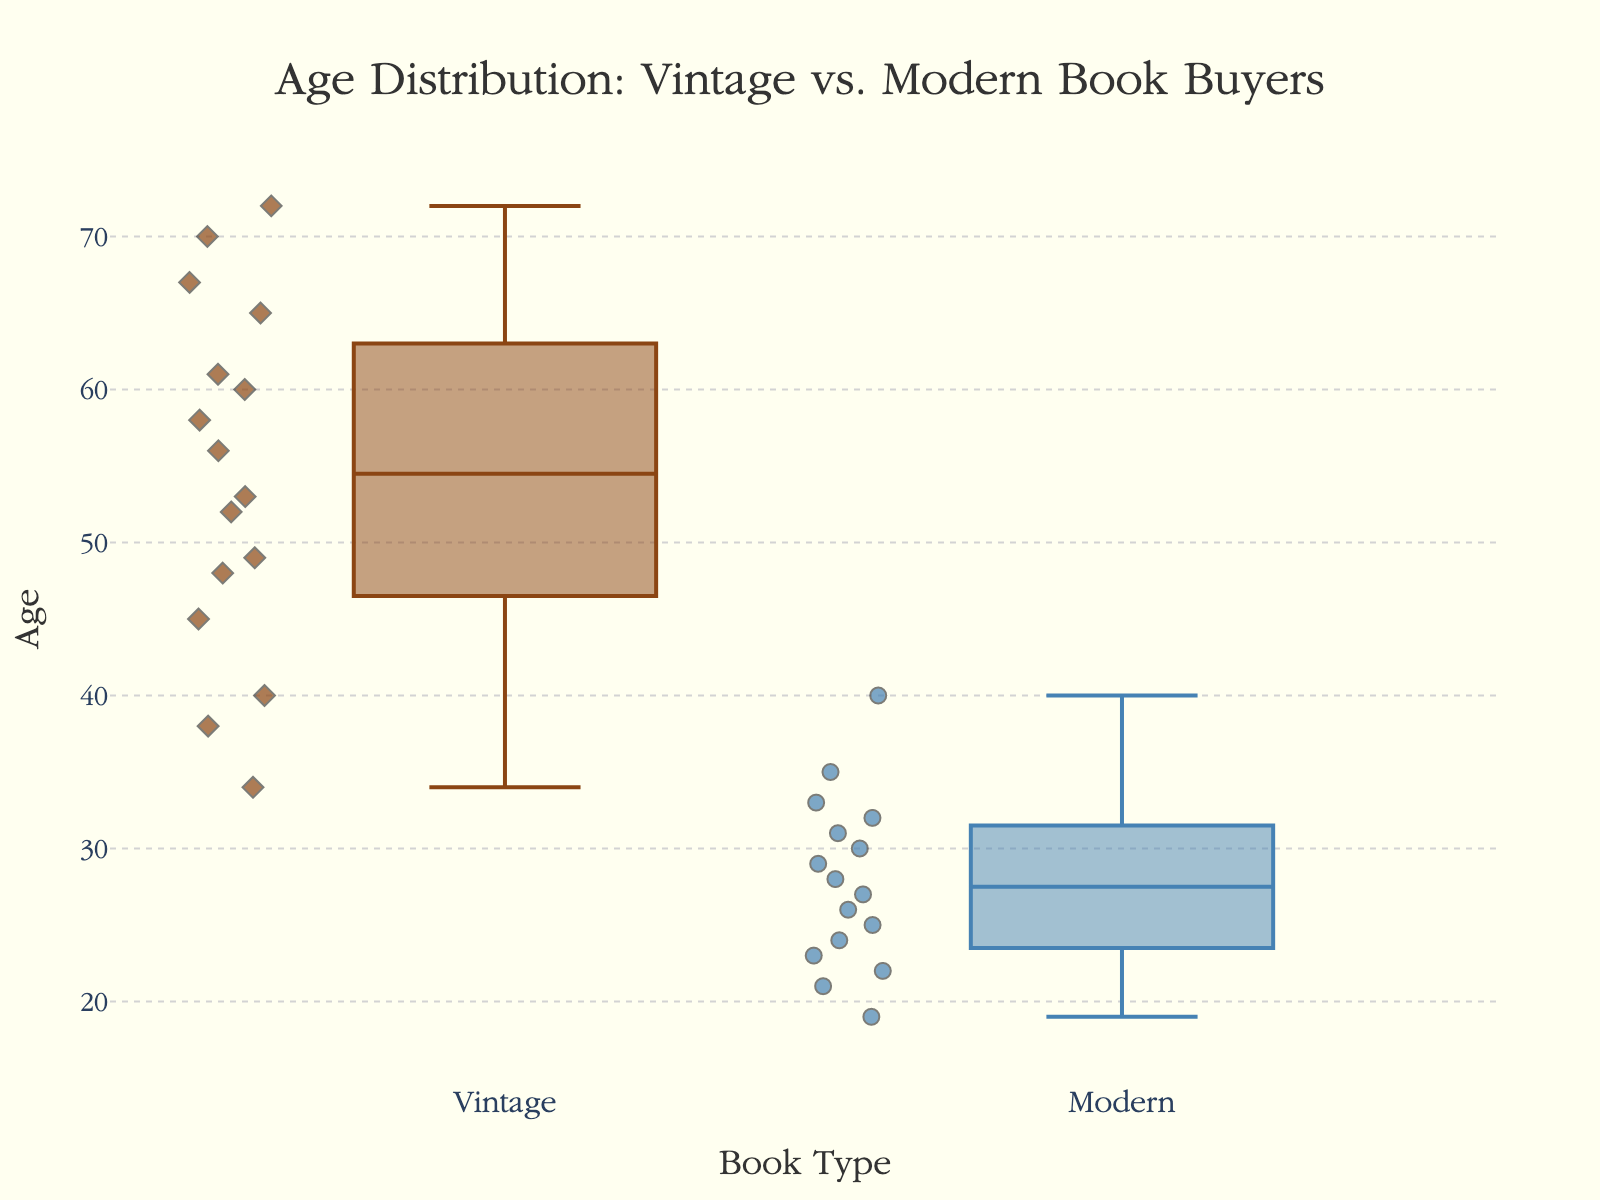what is the title of the plot? The title of the plot is typically prominently displayed at the top and summarizes the main theme or variable being depicted. In this case, it reads 'Age Distribution: Vintage vs. Modern Book Buyers'.
Answer: Age Distribution: Vintage vs. Modern Book Buyers what are the age ranges depicted on the y-axis? The y-axis represents the age of the customers, and the specific range can be read directly from the axis labels. Here, it ranges from 15 to 75.
Answer: 15 to 75 how many data points are in the 'Vintage' category? By looking at the number of markers (dots or symbols) on the 'Vintage' box, we can count them to find the number of data points. There are 16 individual data points for 'Vintage' book buyers.
Answer: 16 which category has a higher median age? The median age is represented by the line within the box. By comparing the positions of these lines in 'Vintage' and 'Modern', it's clear the median age for 'Vintage' buyers is higher.
Answer: Vintage what is the interquartile range (IQR) for the 'Modern' category? The IQR is the difference between the third quartile (top edge of the box) and the first quartile (bottom edge of the box). For 'Modern', the top of the box is around 32 and the bottom is around 24. Therefore, IQR = 32 - 24.
Answer: 8 which category exhibits a wider spread of ages? The spread of ages can be estimated by looking at the length of the whiskers and the box. The 'Vintage' category has a wider spread, extending from around 34 to 72, whereas 'Modern' is from about 19 to 40.
Answer: Vintage what are the lower and upper fences of the 'Vintage' category? The lower fence is the bottom whisker and the upper fence is the top whisker of the box plot. For 'Vintage', the lower fence is about 34 and the upper fence is around 72.
Answer: 34, 72 are there any outliers in the 'Modern' category? Outliers are points that fall outside the whiskers. For the 'Modern' box plot, there doesn't appear to be any points outside the whiskers, indicating no outliers.
Answer: No does any group have overlapping interquartile ranges? By comparing the boxes representing the IQRs, we can see if there's an overlap. There is no overlap between the IQRs of 'Vintage' and 'Modern' categories.
Answer: No what age group has a more concentrated distribution? A more concentrated distribution means a smaller IQR. The 'Modern' category has a smaller IQR (about 8) compared to the 'Vintage' category, indicating a more concentrated distribution of ages.
Answer: Modern 